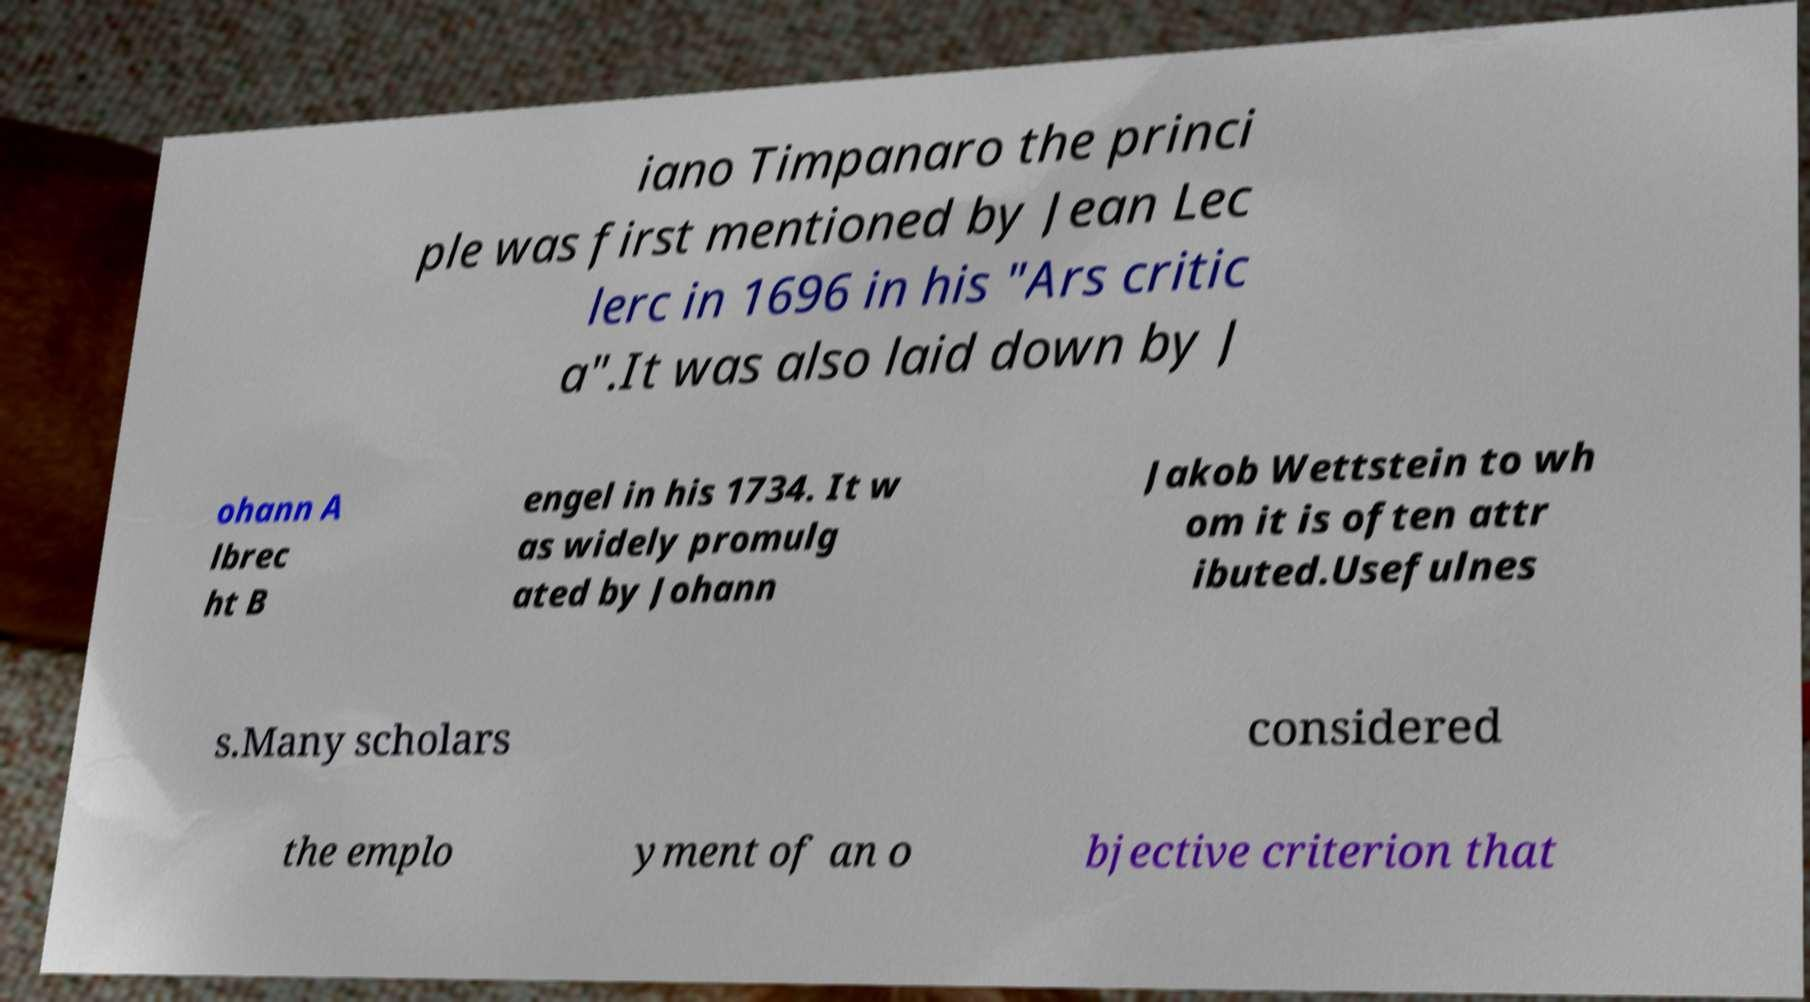I need the written content from this picture converted into text. Can you do that? iano Timpanaro the princi ple was first mentioned by Jean Lec lerc in 1696 in his "Ars critic a".It was also laid down by J ohann A lbrec ht B engel in his 1734. It w as widely promulg ated by Johann Jakob Wettstein to wh om it is often attr ibuted.Usefulnes s.Many scholars considered the emplo yment of an o bjective criterion that 